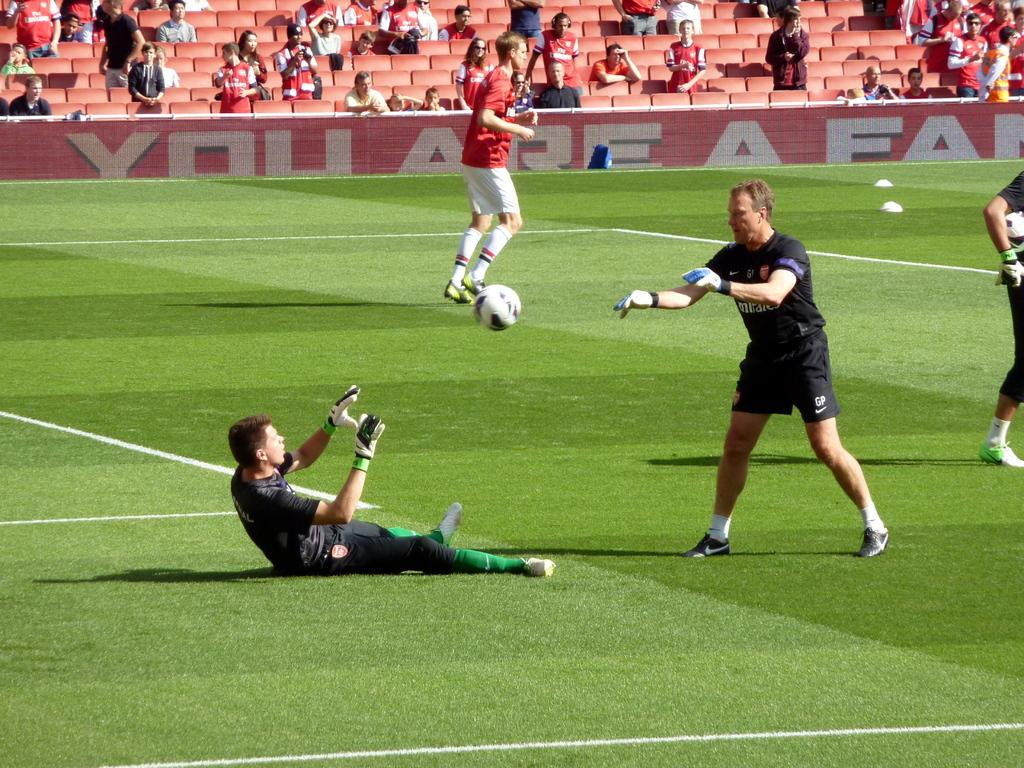<image>
Write a terse but informative summary of the picture. soccer players playing in a field with a sign that says ' you are a family'' 